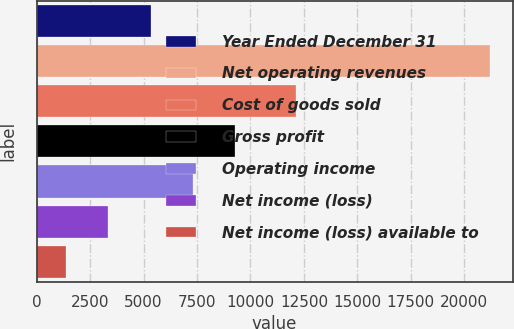Convert chart to OTSL. <chart><loc_0><loc_0><loc_500><loc_500><bar_chart><fcel>Year Ended December 31<fcel>Net operating revenues<fcel>Cost of goods sold<fcel>Gross profit<fcel>Operating income<fcel>Net income (loss)<fcel>Net income (loss) available to<nl><fcel>5331.6<fcel>21202<fcel>12132<fcel>9299.2<fcel>7315.4<fcel>3347.8<fcel>1364<nl></chart> 